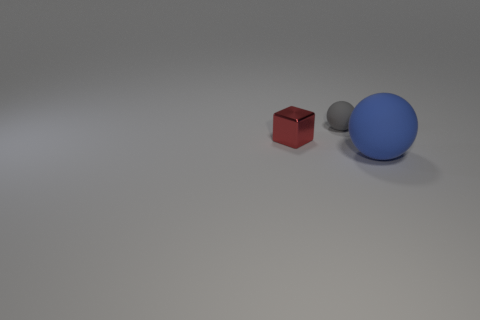What is the color of the object that is made of the same material as the large sphere? The object that appears to be made of the same material as the large sphere is the smaller sphere, which is a shade of gray. 